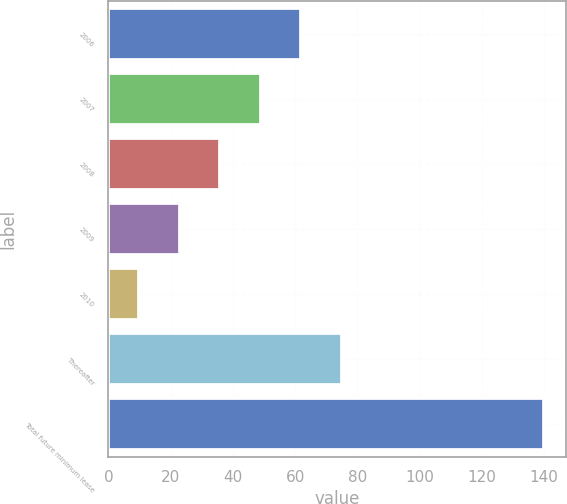Convert chart. <chart><loc_0><loc_0><loc_500><loc_500><bar_chart><fcel>2006<fcel>2007<fcel>2008<fcel>2009<fcel>2010<fcel>Thereafter<fcel>Total future minimum lease<nl><fcel>62<fcel>49<fcel>36<fcel>23<fcel>10<fcel>75<fcel>140<nl></chart> 